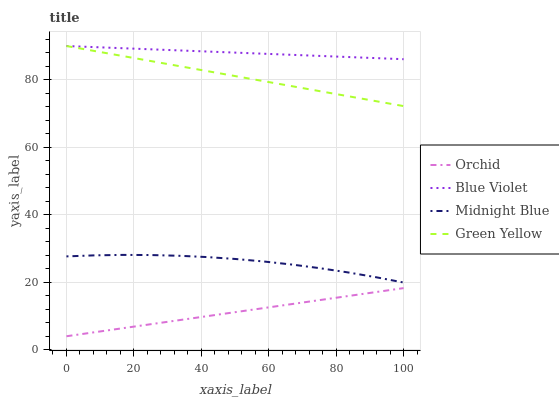Does Orchid have the minimum area under the curve?
Answer yes or no. Yes. Does Blue Violet have the maximum area under the curve?
Answer yes or no. Yes. Does Midnight Blue have the minimum area under the curve?
Answer yes or no. No. Does Midnight Blue have the maximum area under the curve?
Answer yes or no. No. Is Green Yellow the smoothest?
Answer yes or no. Yes. Is Midnight Blue the roughest?
Answer yes or no. Yes. Is Blue Violet the smoothest?
Answer yes or no. No. Is Blue Violet the roughest?
Answer yes or no. No. Does Midnight Blue have the lowest value?
Answer yes or no. No. Does Blue Violet have the highest value?
Answer yes or no. Yes. Does Midnight Blue have the highest value?
Answer yes or no. No. Is Midnight Blue less than Green Yellow?
Answer yes or no. Yes. Is Green Yellow greater than Orchid?
Answer yes or no. Yes. Does Blue Violet intersect Green Yellow?
Answer yes or no. Yes. Is Blue Violet less than Green Yellow?
Answer yes or no. No. Is Blue Violet greater than Green Yellow?
Answer yes or no. No. Does Midnight Blue intersect Green Yellow?
Answer yes or no. No. 